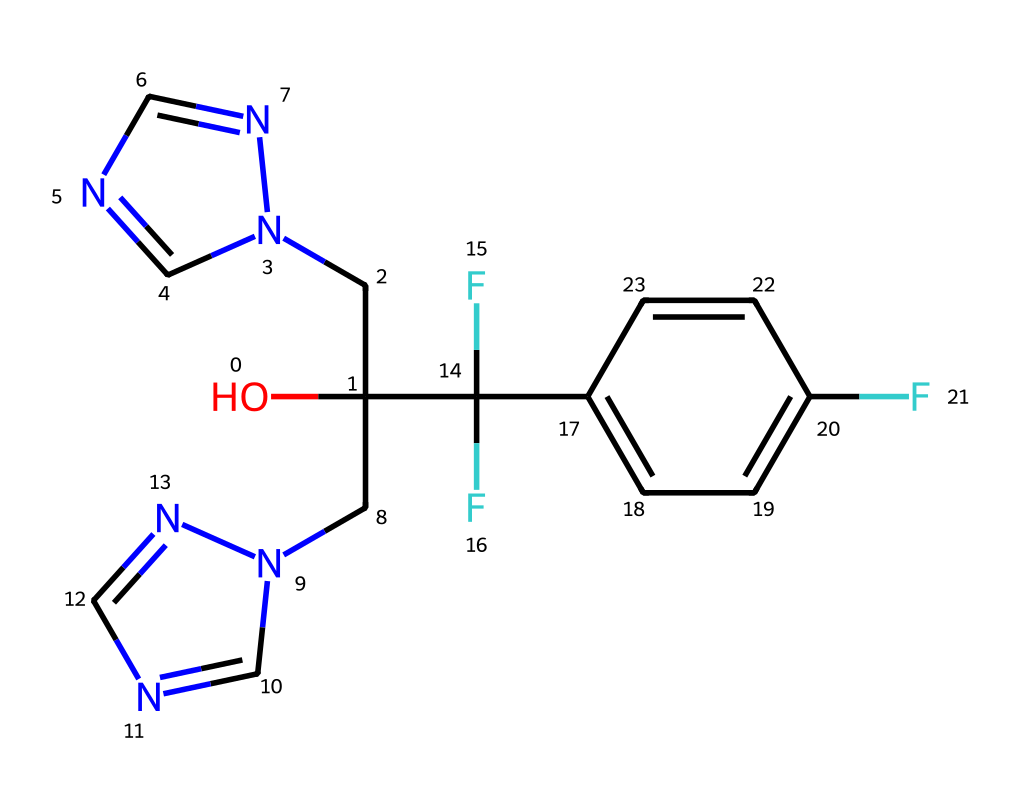What is the chemical name of the compound represented by this SMILES? The SMILES provided corresponds to fluconazole, a well-known antifungal medication. It can be determined by interpreting the structure described by the SMILES string.
Answer: fluconazole How many nitrogen atoms are present in the compound? By analyzing the SMILES representation, there are four nitrogen atoms indicated by the "n" in the structure. Counting each instance of "n," we find a total of four.
Answer: four What is the total number of carbon atoms in this compound? In the SMILES, each "C" represents a carbon atom. By counting all the occurrences of "C," including the carbon atoms in the cyclopropane and those attached to functional groups, we find there are ten carbon atoms in total.
Answer: ten Does the structure contain any fluorine atoms? The presence of "F" in the SMILES indicates the molecule contains fluorine atoms. Counting them, we find two occurrences of "F."
Answer: two What functional groups are present in fluconazole? The molecule includes hydroxyl (–OH) groups and fluorine substituents based on the structure indicated by the SMILES. The "O" and "C(F)(F)" sections correspond to these groups.
Answer: hydroxyl; fluorine substituents What is the likely role of the fluorine atoms in fluconazole? The fluorine atoms likely enhance the compound's lipophilicity, improving its ability to penetrate fungal cell membranes, which is critical for its function as an antifungal agent.
Answer: enhance lipophilicity What common application is associated with fluconazole? Fluconazole is commonly prescribed to treat fungal infections, especially in immunocompromised patients or those with candida infections. This application is well-documented in medical literature.
Answer: treat fungal infections 